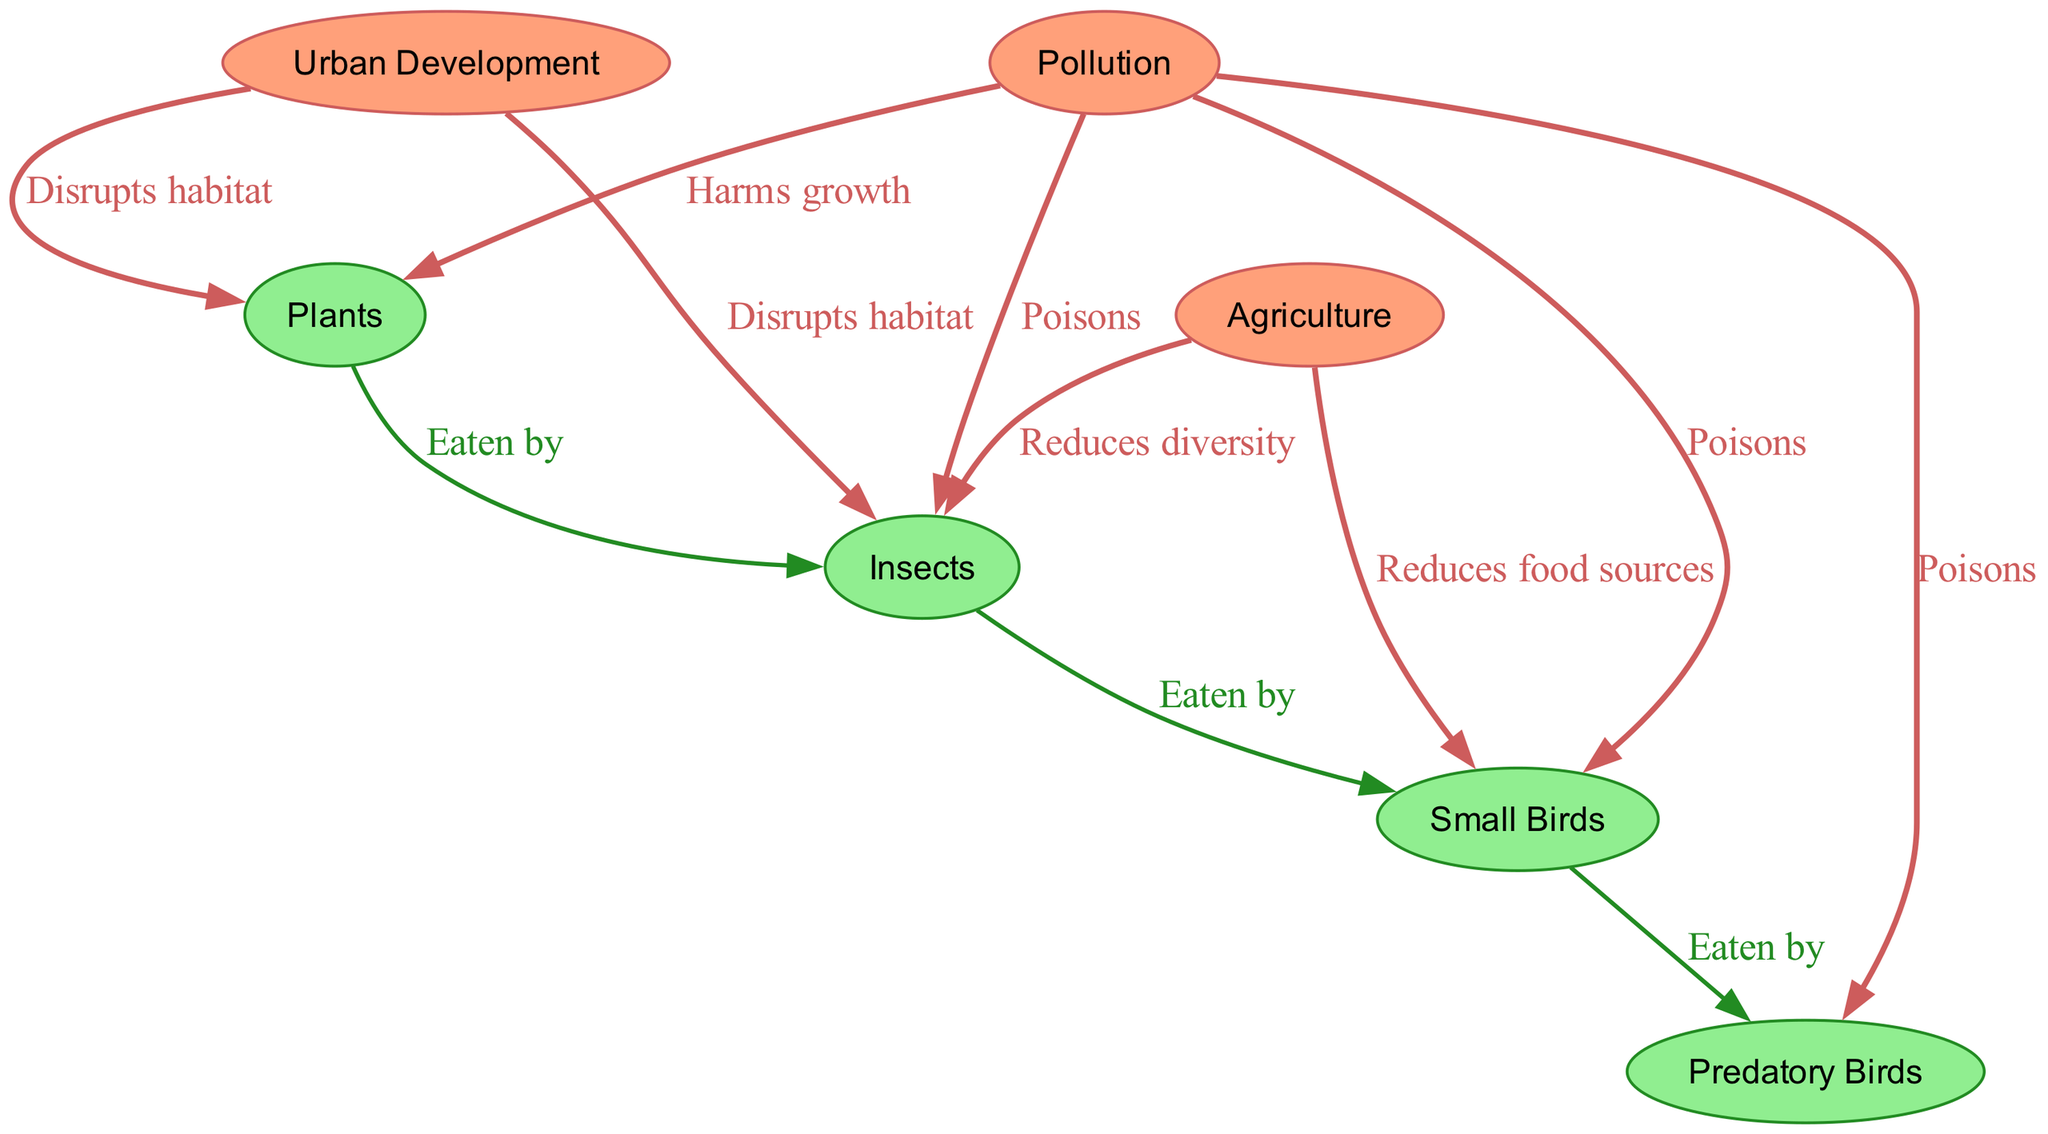What are the primary producers in this food chain? The diagram identifies "Plants" as the primary producers, which are responsible for converting sunlight into energy through photosynthesis.
Answer: Plants How many consumer levels are represented in the diagram? The diagram has three consumer levels: primary consumers (insects), secondary consumers (small birds), and tertiary consumers (predatory birds), which totals three levels.
Answer: 3 What negatively impacts both plants and insects according to the diagram? The diagram shows that "Urban Development" disrupts habitats for both "Plants" and "Insects," indicating its negative impact on their populations.
Answer: Urban Development Which human activity reduces food sources for small birds? The diagram indicates that "Agriculture" reduces food sources for "Small Birds," along with diminishing insect diversity which affects their food availability.
Answer: Agriculture How does pollution affect predatory birds in the food chain? The diagram describes that "Pollution" poisons "Predatory Birds," linking its detrimental effects directly to higher-level consumers in the food chain.
Answer: Poisons What is the relationship between insects and small birds? According to the diagram, "Insects" are "Eaten by" "Small Birds," establishing a direct predator-prey relationship between these two nodes.
Answer: Eaten by Which node is connected to three different nodes as a source of negative impact? "Pollution" connects to "Plants," "Insects," and "Small Birds," indicating that it has multiple negative impacts on these components of the ecosystem.
Answer: Pollution What effect do urban development and agriculture have on plants? Both "Urban Development" and "Agriculture" disrupt habitats and reduce diversity, respectively, resulting in harmful effects on "Plants."
Answer: Disrupts habitat; Reduces diversity 